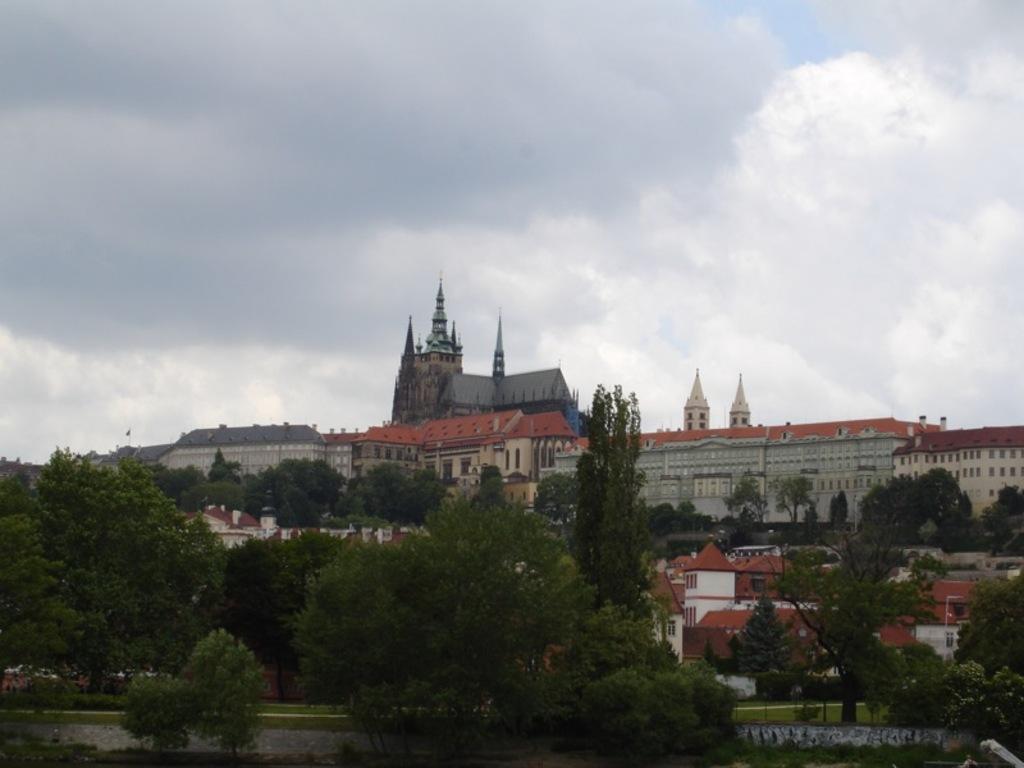Could you give a brief overview of what you see in this image? In this image, in the middle there are buildings, trees, grass, sky and clouds. 